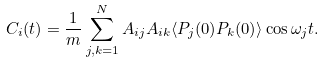Convert formula to latex. <formula><loc_0><loc_0><loc_500><loc_500>C _ { i } ( t ) = \frac { 1 } { m } \sum _ { j , k = 1 } ^ { N } A _ { i j } A _ { i k } \langle P _ { j } ( 0 ) P _ { k } ( 0 ) \rangle \cos \omega _ { j } t .</formula> 